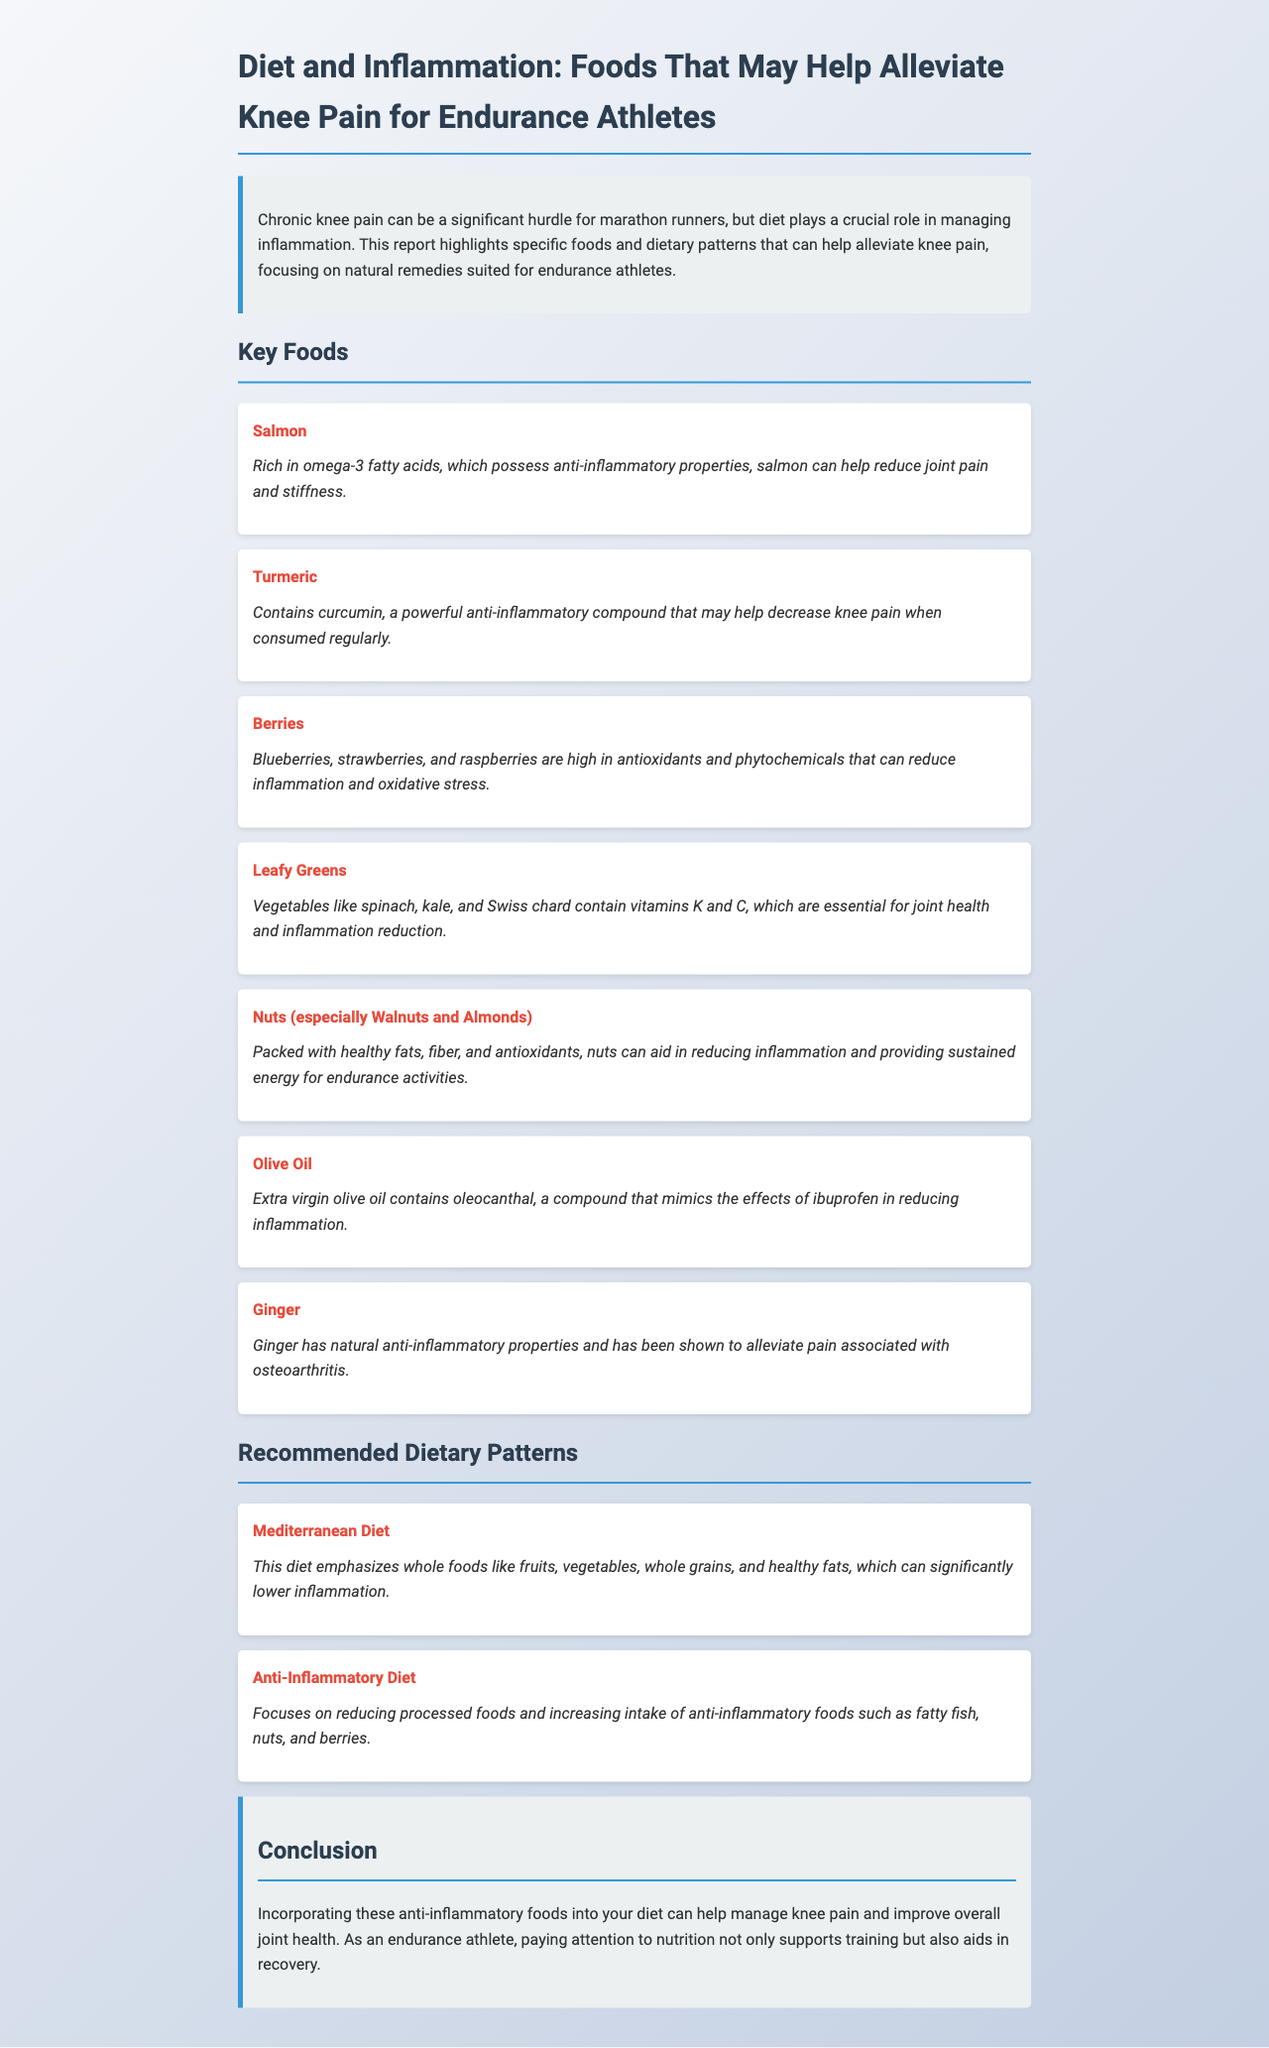What is the primary focus of the report? The report emphasizes the role of diet in managing inflammation related to knee pain for endurance athletes.
Answer: Diet in managing inflammation What type of diet is recommended for inflamed joints? The "Mediterranean Diet" is suggested due to its emphasis on whole foods.
Answer: Mediterranean Diet Which food item is noted for containing omega-3 fatty acids? Salmon is highlighted for its rich omega-3 fatty acids that help reduce joint pain.
Answer: Salmon What compound in turmeric is beneficial for knee pain? Curcumin is identified as the powerful anti-inflammatory compound in turmeric.
Answer: Curcumin Which two nuts are mentioned as especially beneficial? Walnuts and almonds are specified for their healthy fats and anti-inflammatory properties.
Answer: Walnuts and almonds How does extra virgin olive oil help with inflammation? Olive oil contains oleocanthal, which mimics ibuprofen in reducing inflammation.
Answer: Oleocanthal What is a key benefit of consuming berries? Berries are noted for their high antioxidants that can reduce inflammation.
Answer: High antioxidants What dietary pattern reduces processed foods? The "Anti-Inflammatory Diet" focuses on reducing processed foods and increasing anti-inflammatory foods.
Answer: Anti-Inflammatory Diet In summary, what do these dietary recommendations support for endurance athletes? The recommendations support better management of knee pain and overall joint health for endurance athletes.
Answer: Knee pain management and joint health 